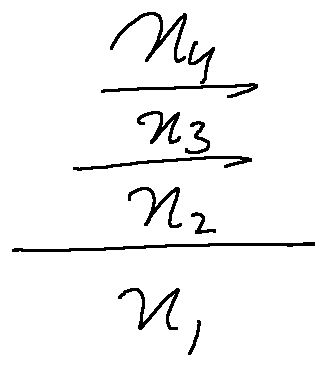<formula> <loc_0><loc_0><loc_500><loc_500>\frac { \frac { \frac { x _ { 4 } } { x _ { 3 } } } { x _ { 2 } } } { x _ { 1 } }</formula> 